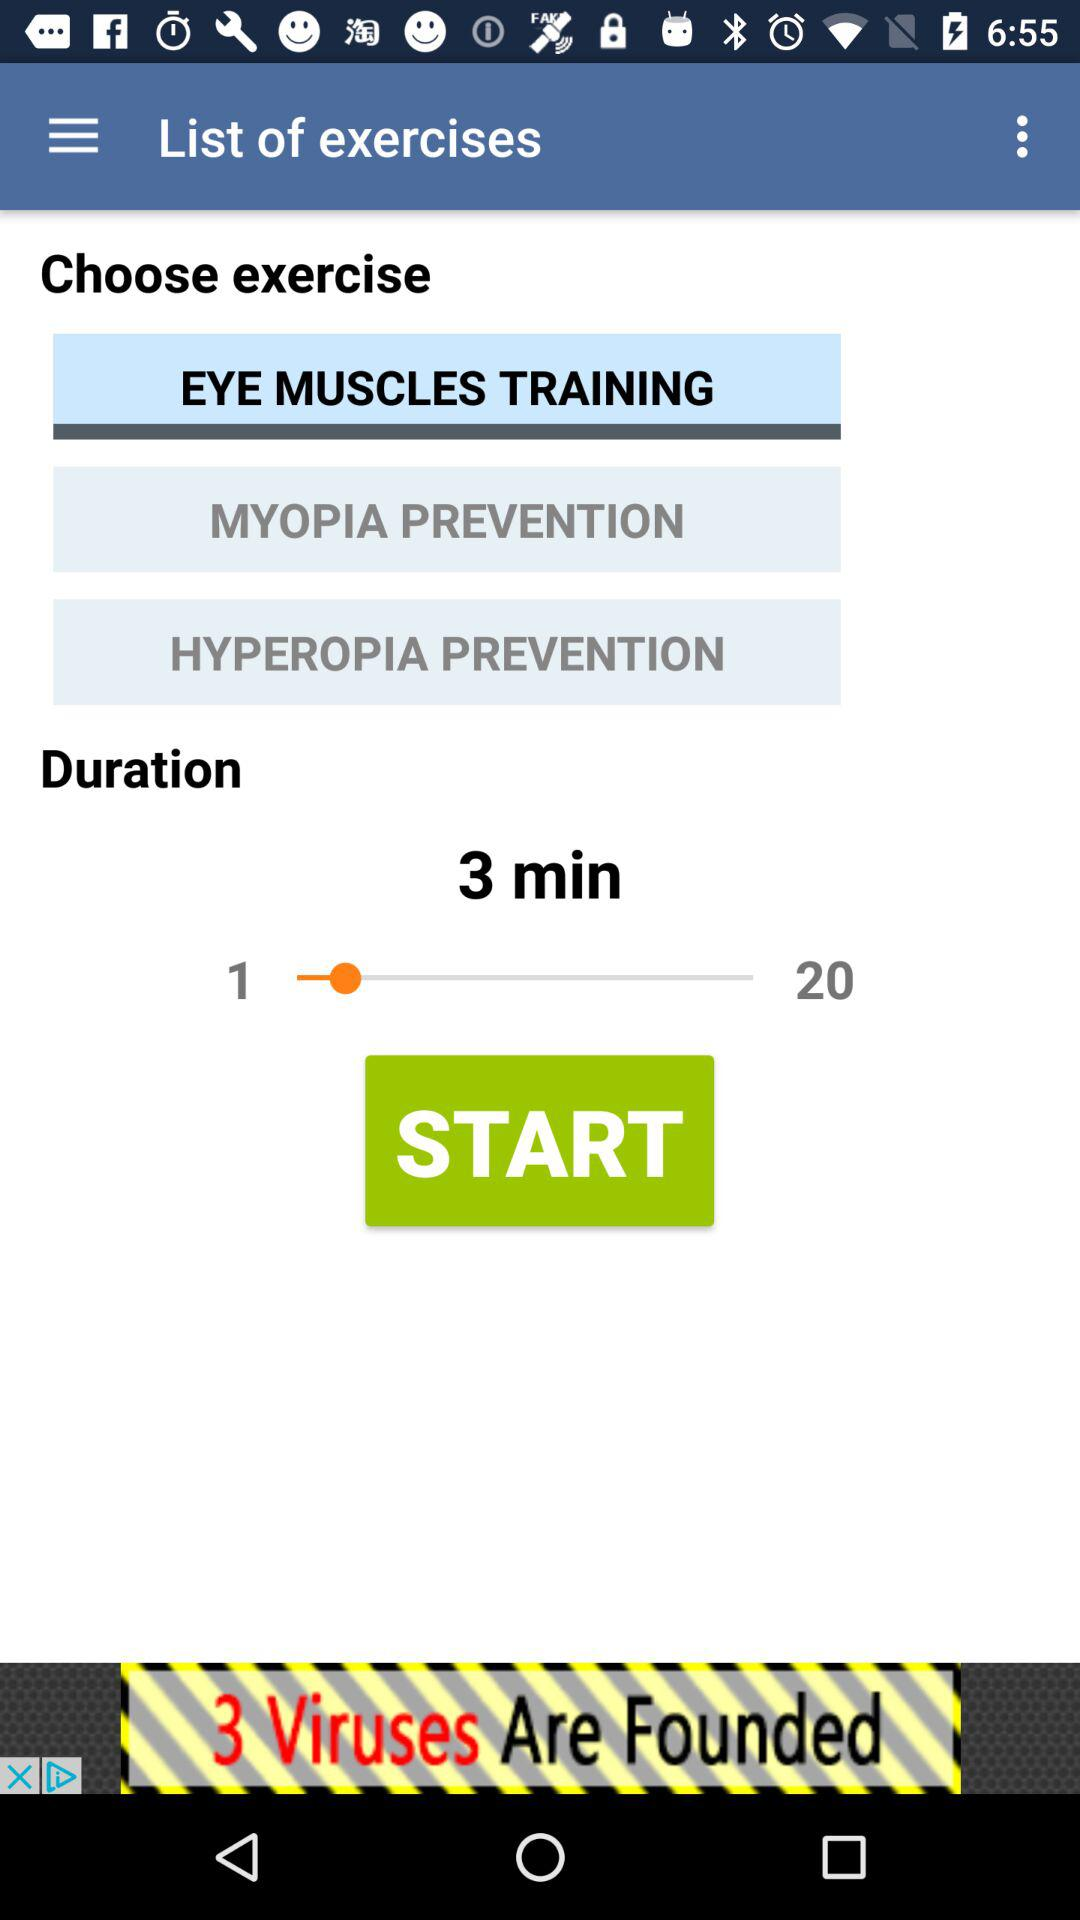How many exercises are there in total?
Answer the question using a single word or phrase. 3 